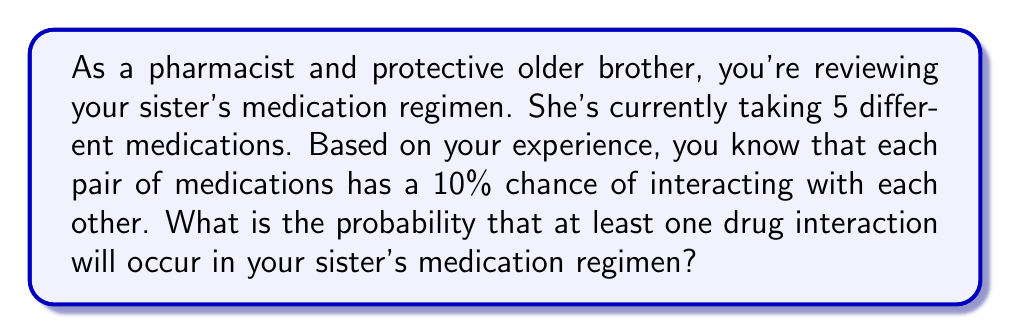Could you help me with this problem? Let's approach this step-by-step:

1) First, we need to calculate the total number of possible medication pairs. With 5 medications, we can calculate this using the combination formula:

   $${5 \choose 2} = \frac{5!}{2!(5-2)!} = \frac{5 \cdot 4}{2 \cdot 1} = 10$$

2) Now, we know that each pair has a 10% (or 0.1) chance of interacting. Let's calculate the probability of no interaction for each pair:

   $$P(\text{no interaction for a pair}) = 1 - 0.1 = 0.9$$

3) For at least one interaction to occur, we can calculate the complement of the probability that no interactions occur at all. For no interactions to occur, all 10 pairs must not interact. So:

   $$P(\text{no interactions at all}) = 0.9^{10}$$

4) Therefore, the probability of at least one interaction is:

   $$P(\text{at least one interaction}) = 1 - P(\text{no interactions at all})$$
   $$= 1 - 0.9^{10}$$
   $$= 1 - 0.3486784401$$
   $$= 0.6513215599$$

5) Converting to a percentage:

   $$0.6513215599 \times 100\% = 65.13\%$$
Answer: The probability that at least one drug interaction will occur in your sister's medication regimen is approximately 65.13%. 